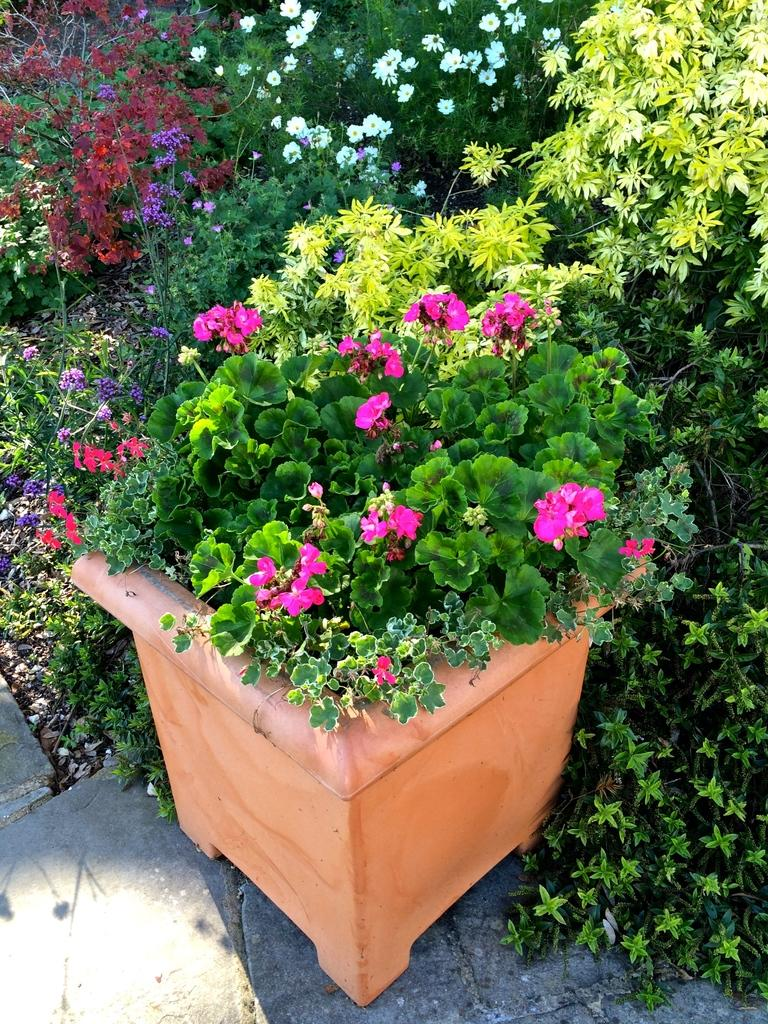What type of living organisms can be seen in the image? There are flowers and plants visible in the image. What is the container for the plants in the image? There is a pot in the image. What else can be seen in the image besides the plants and pot? There are other objects in the image. What is visible at the bottom of the image? The floor is visible at the bottom of the image. What type of blade is being used to cut the train in the image? There is no train or blade present in the image. 